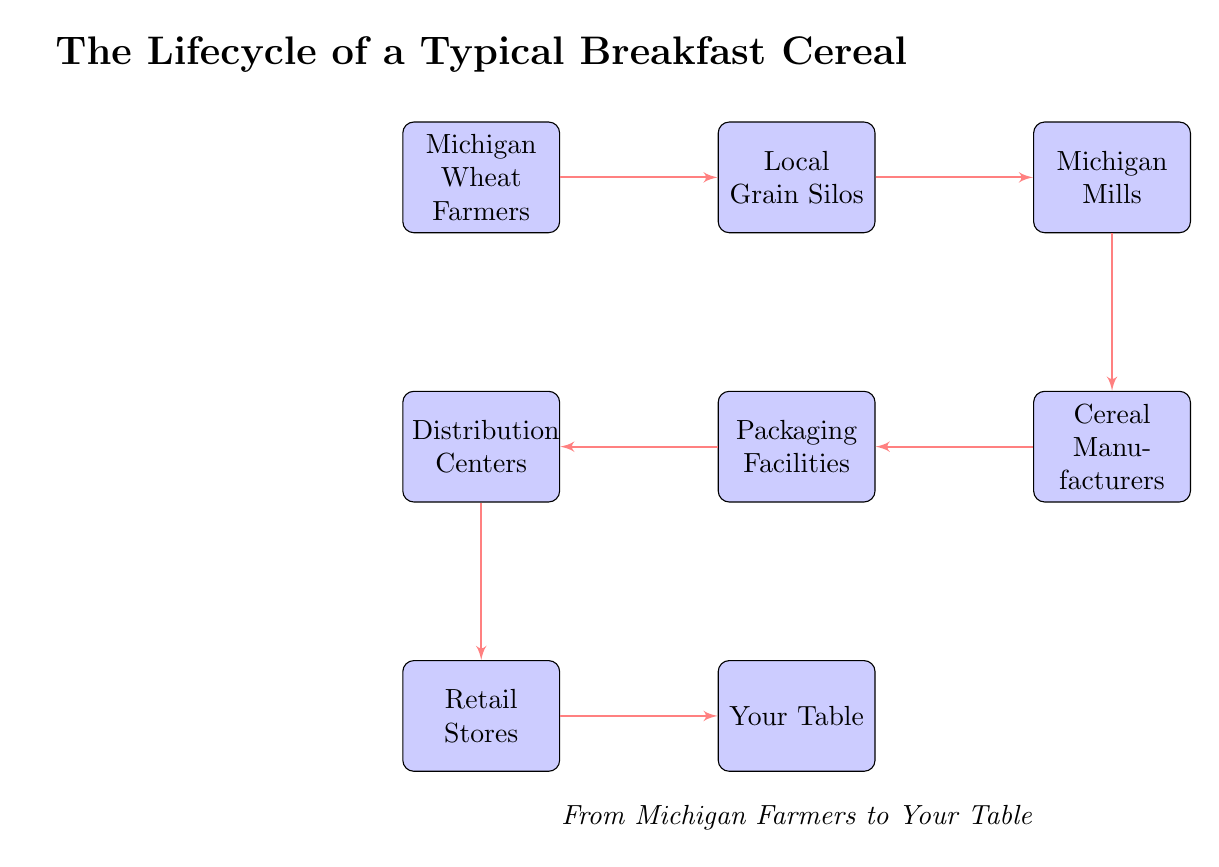What is the first step in the lifecycle of a breakfast cereal? The first step is represented by the node "Michigan Wheat Farmers," indicating the initial source of the ingredients for the cereal.
Answer: Michigan Wheat Farmers How many nodes are present in the diagram? By counting the blocks, there are a total of eight nodes including "Your Table."
Answer: 8 What connects "Cereal Manufacturers" and "Packaging Facilities"? The diagram shows a direct line, indicating that the Cereal Manufacturers send their products to the Packaging Facilities.
Answer: Packaging Facilities Which node is directly before "Your Table"? The node that feeds into "Your Table" is "Retail Stores," which represents the last step before the cereal reaches consumers.
Answer: Retail Stores Which entity receives grain from local silos? The "Michigan Mills" node is the next step in the flow after the local grain silos, indicating it is the entity that processes the grain.
Answer: Michigan Mills What is the role of "Distribution Centers" in the lifecycle? The Distribution Centers are responsible for connecting the Packaging Facilities to the Retail Stores before the final product reaches consumers.
Answer: Distribution Centers Which two nodes are connected by the line that follows the "Michigan Mills"? The line connects "Michigan Mills" to "Cereal Manufacturers," showing the flow of processed grain to the production of cereal.
Answer: Cereal Manufacturers Who are the stakeholders involved in the lifecycle before reaching the consumer? The stakeholders involved comprise Michigan Wheat Farmers, Local Grain Silos, Michigan Mills, Cereal Manufacturers, Packaging Facilities, and Distribution Centers.
Answer: Six stakeholders What type of diagram is this and what does it represent? This is a food chain diagram that illustrates the steps involved in bringing a breakfast cereal from its agricultural origins to the consumer's table.
Answer: Food chain diagram 